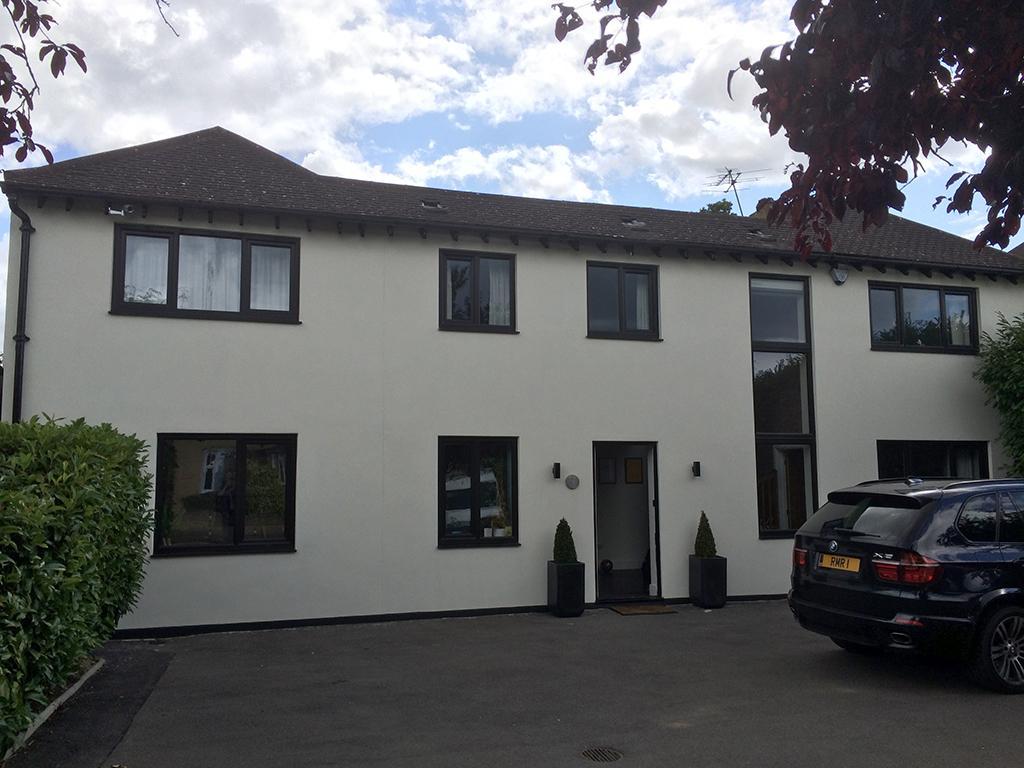Can you describe this image briefly? In this picture we can see a car on the ground, house plants, door mat, frames on the wall, curtains, building with windows and in the background we can see the sky with clouds. 